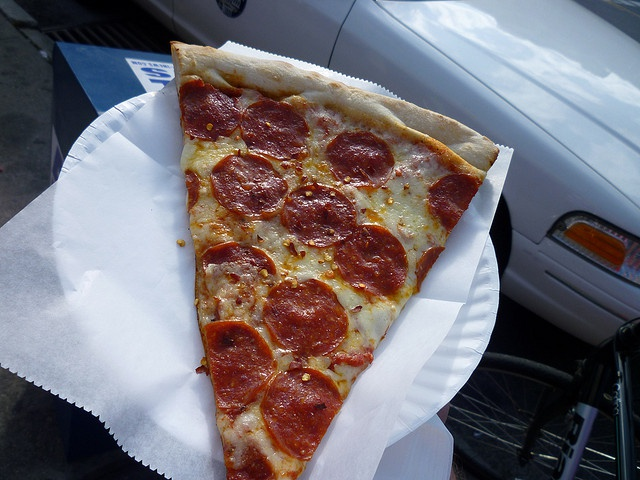Describe the objects in this image and their specific colors. I can see pizza in purple, maroon, gray, and tan tones, car in purple, gray, lightblue, black, and lightgray tones, and bicycle in purple, black, navy, and blue tones in this image. 